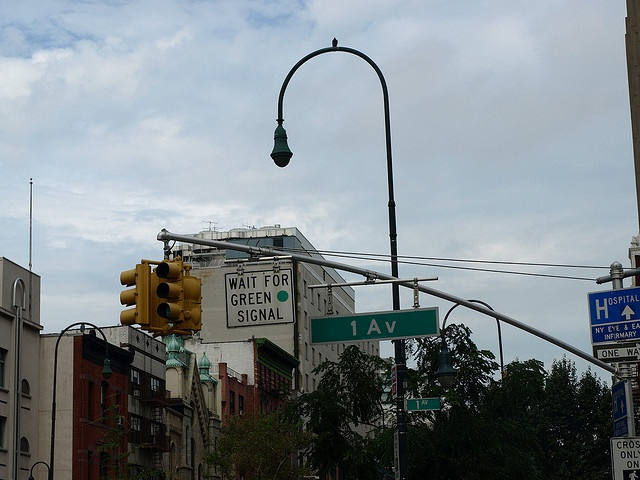Describe the objects in this image and their specific colors. I can see traffic light in lightblue, black, olive, and maroon tones, traffic light in lightblue, black, maroon, and olive tones, and traffic light in lightblue, maroon, black, and olive tones in this image. 